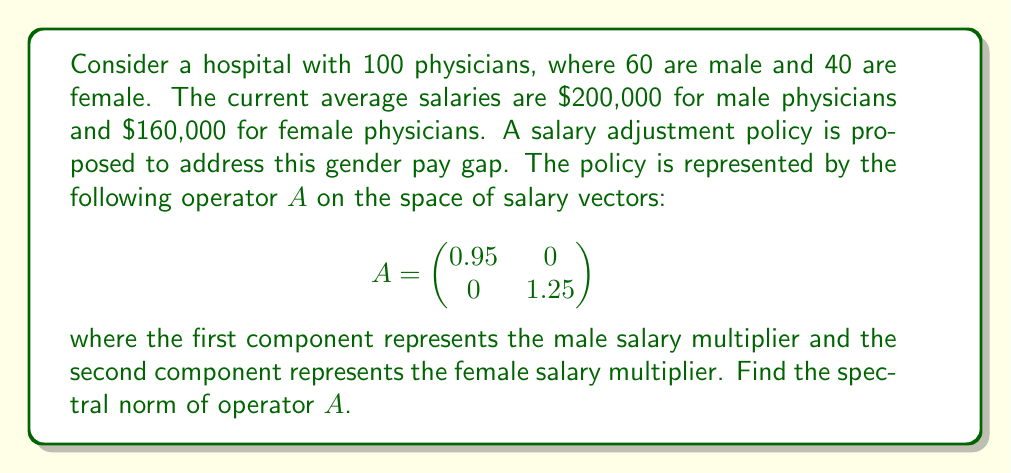Can you answer this question? To find the spectral norm of operator $A$, we follow these steps:

1) The spectral norm of a matrix is equal to the square root of the largest eigenvalue of $A^TA$, where $A^T$ is the transpose of $A$.

2) First, let's calculate $A^TA$:

   $$A^TA = \begin{pmatrix}
   0.95 & 0 \\
   0 & 1.25
   \end{pmatrix} \begin{pmatrix}
   0.95 & 0 \\
   0 & 1.25
   \end{pmatrix} = \begin{pmatrix}
   0.9025 & 0 \\
   0 & 1.5625
   \end{pmatrix}$$

3) The eigenvalues of $A^TA$ are the diagonal elements: $\lambda_1 = 0.9025$ and $\lambda_2 = 1.5625$.

4) The largest eigenvalue is $\lambda_2 = 1.5625$.

5) The spectral norm is the square root of this largest eigenvalue:

   $$\|A\| = \sqrt{1.5625} = 1.25$$

This result indicates that the maximum "stretching" factor of the salary adjustment policy is 1.25, which corresponds to the 25% increase for female physicians' salaries.
Answer: $1.25$ 